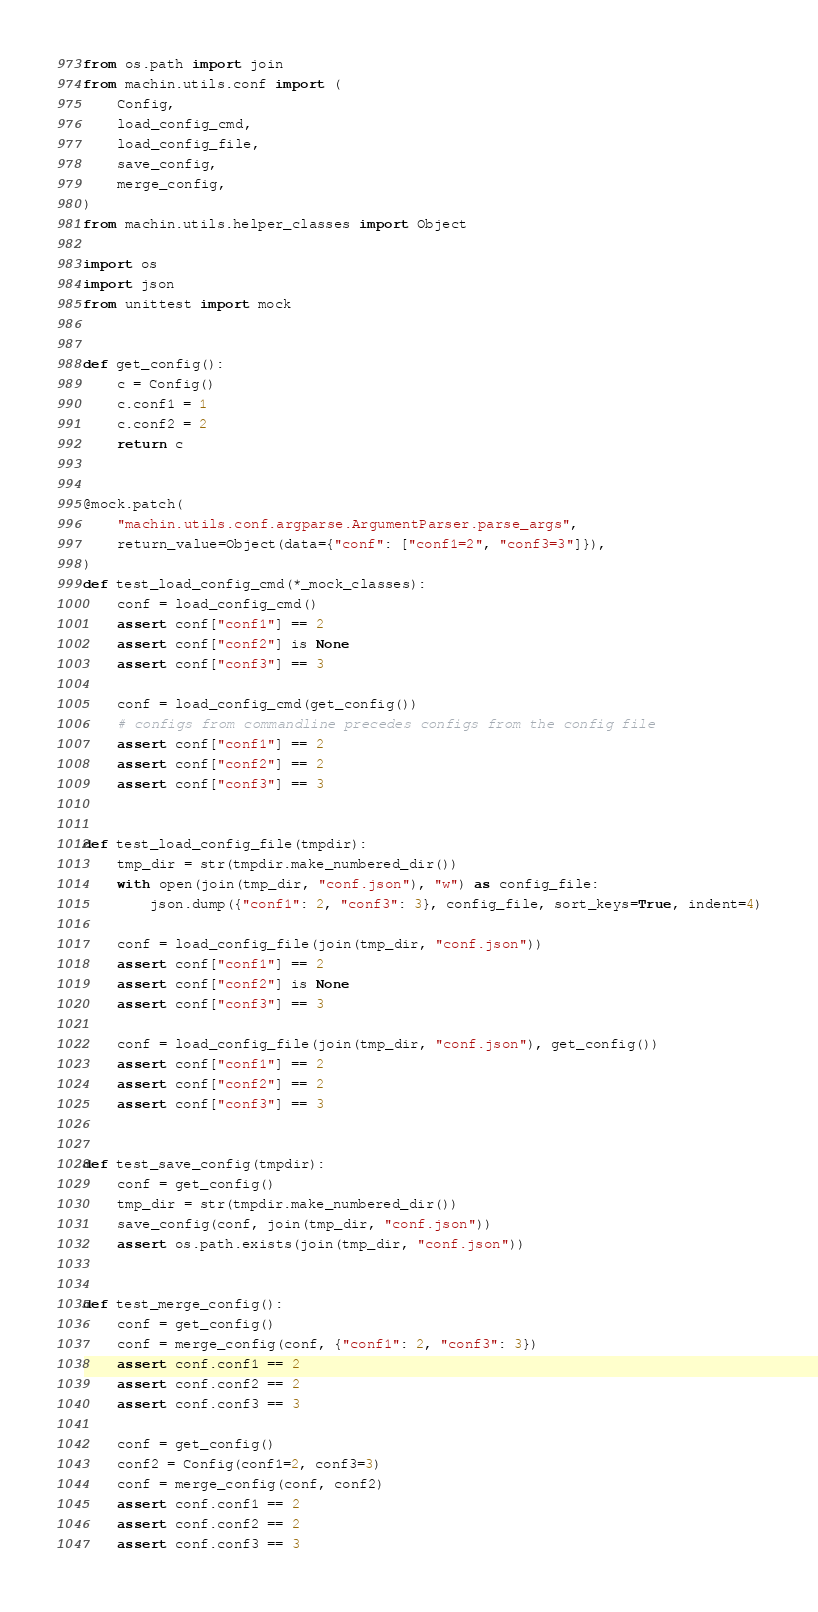<code> <loc_0><loc_0><loc_500><loc_500><_Python_>from os.path import join
from machin.utils.conf import (
    Config,
    load_config_cmd,
    load_config_file,
    save_config,
    merge_config,
)
from machin.utils.helper_classes import Object

import os
import json
from unittest import mock


def get_config():
    c = Config()
    c.conf1 = 1
    c.conf2 = 2
    return c


@mock.patch(
    "machin.utils.conf.argparse.ArgumentParser.parse_args",
    return_value=Object(data={"conf": ["conf1=2", "conf3=3"]}),
)
def test_load_config_cmd(*_mock_classes):
    conf = load_config_cmd()
    assert conf["conf1"] == 2
    assert conf["conf2"] is None
    assert conf["conf3"] == 3

    conf = load_config_cmd(get_config())
    # configs from commandline precedes configs from the config file
    assert conf["conf1"] == 2
    assert conf["conf2"] == 2
    assert conf["conf3"] == 3


def test_load_config_file(tmpdir):
    tmp_dir = str(tmpdir.make_numbered_dir())
    with open(join(tmp_dir, "conf.json"), "w") as config_file:
        json.dump({"conf1": 2, "conf3": 3}, config_file, sort_keys=True, indent=4)

    conf = load_config_file(join(tmp_dir, "conf.json"))
    assert conf["conf1"] == 2
    assert conf["conf2"] is None
    assert conf["conf3"] == 3

    conf = load_config_file(join(tmp_dir, "conf.json"), get_config())
    assert conf["conf1"] == 2
    assert conf["conf2"] == 2
    assert conf["conf3"] == 3


def test_save_config(tmpdir):
    conf = get_config()
    tmp_dir = str(tmpdir.make_numbered_dir())
    save_config(conf, join(tmp_dir, "conf.json"))
    assert os.path.exists(join(tmp_dir, "conf.json"))


def test_merge_config():
    conf = get_config()
    conf = merge_config(conf, {"conf1": 2, "conf3": 3})
    assert conf.conf1 == 2
    assert conf.conf2 == 2
    assert conf.conf3 == 3

    conf = get_config()
    conf2 = Config(conf1=2, conf3=3)
    conf = merge_config(conf, conf2)
    assert conf.conf1 == 2
    assert conf.conf2 == 2
    assert conf.conf3 == 3
</code> 